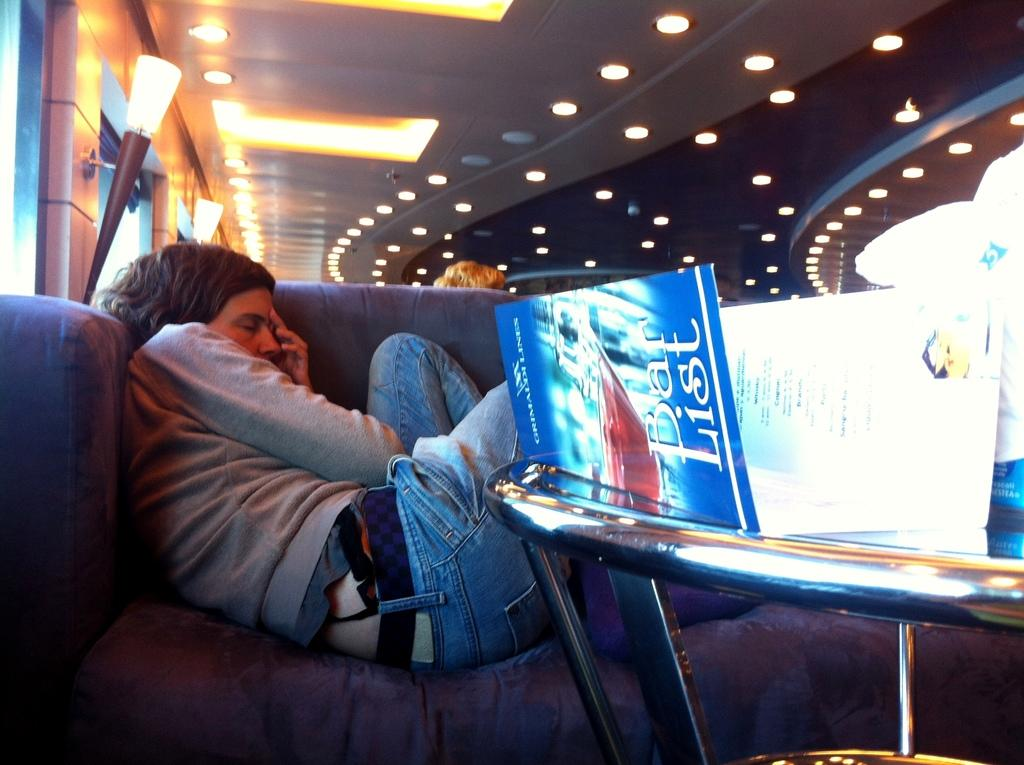Who is present in the image? There is a person in the image. What is the person wearing? The person is wearing clothes. What is the person's position in the image? The person is lying on a sofa. What type of furniture is in the image? There is a sofa in the image. What can be seen above the person? There is a light in the image. What other piece of furniture is in the image? There is a table in the image. What is on the table? There are other objects on the table. What type of work is the person doing in the image? The image does not show the person working or performing any specific task. 